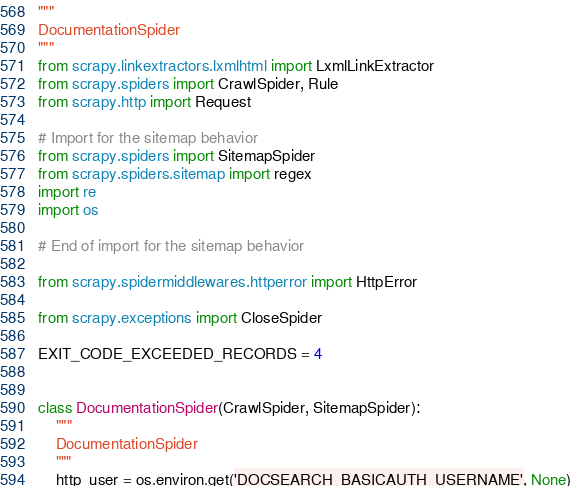<code> <loc_0><loc_0><loc_500><loc_500><_Python_>"""
DocumentationSpider
"""
from scrapy.linkextractors.lxmlhtml import LxmlLinkExtractor
from scrapy.spiders import CrawlSpider, Rule
from scrapy.http import Request

# Import for the sitemap behavior
from scrapy.spiders import SitemapSpider
from scrapy.spiders.sitemap import regex
import re
import os

# End of import for the sitemap behavior

from scrapy.spidermiddlewares.httperror import HttpError

from scrapy.exceptions import CloseSpider

EXIT_CODE_EXCEEDED_RECORDS = 4


class DocumentationSpider(CrawlSpider, SitemapSpider):
    """
    DocumentationSpider
    """
    http_user = os.environ.get('DOCSEARCH_BASICAUTH_USERNAME', None)</code> 